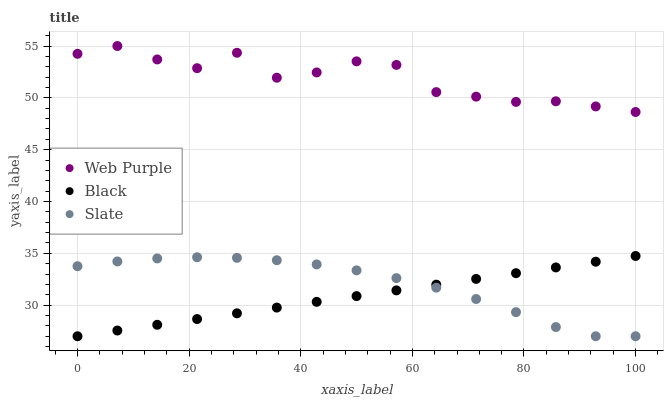Does Black have the minimum area under the curve?
Answer yes or no. Yes. Does Web Purple have the maximum area under the curve?
Answer yes or no. Yes. Does Slate have the minimum area under the curve?
Answer yes or no. No. Does Slate have the maximum area under the curve?
Answer yes or no. No. Is Black the smoothest?
Answer yes or no. Yes. Is Web Purple the roughest?
Answer yes or no. Yes. Is Slate the smoothest?
Answer yes or no. No. Is Slate the roughest?
Answer yes or no. No. Does Black have the lowest value?
Answer yes or no. Yes. Does Web Purple have the highest value?
Answer yes or no. Yes. Does Black have the highest value?
Answer yes or no. No. Is Black less than Web Purple?
Answer yes or no. Yes. Is Web Purple greater than Black?
Answer yes or no. Yes. Does Slate intersect Black?
Answer yes or no. Yes. Is Slate less than Black?
Answer yes or no. No. Is Slate greater than Black?
Answer yes or no. No. Does Black intersect Web Purple?
Answer yes or no. No. 